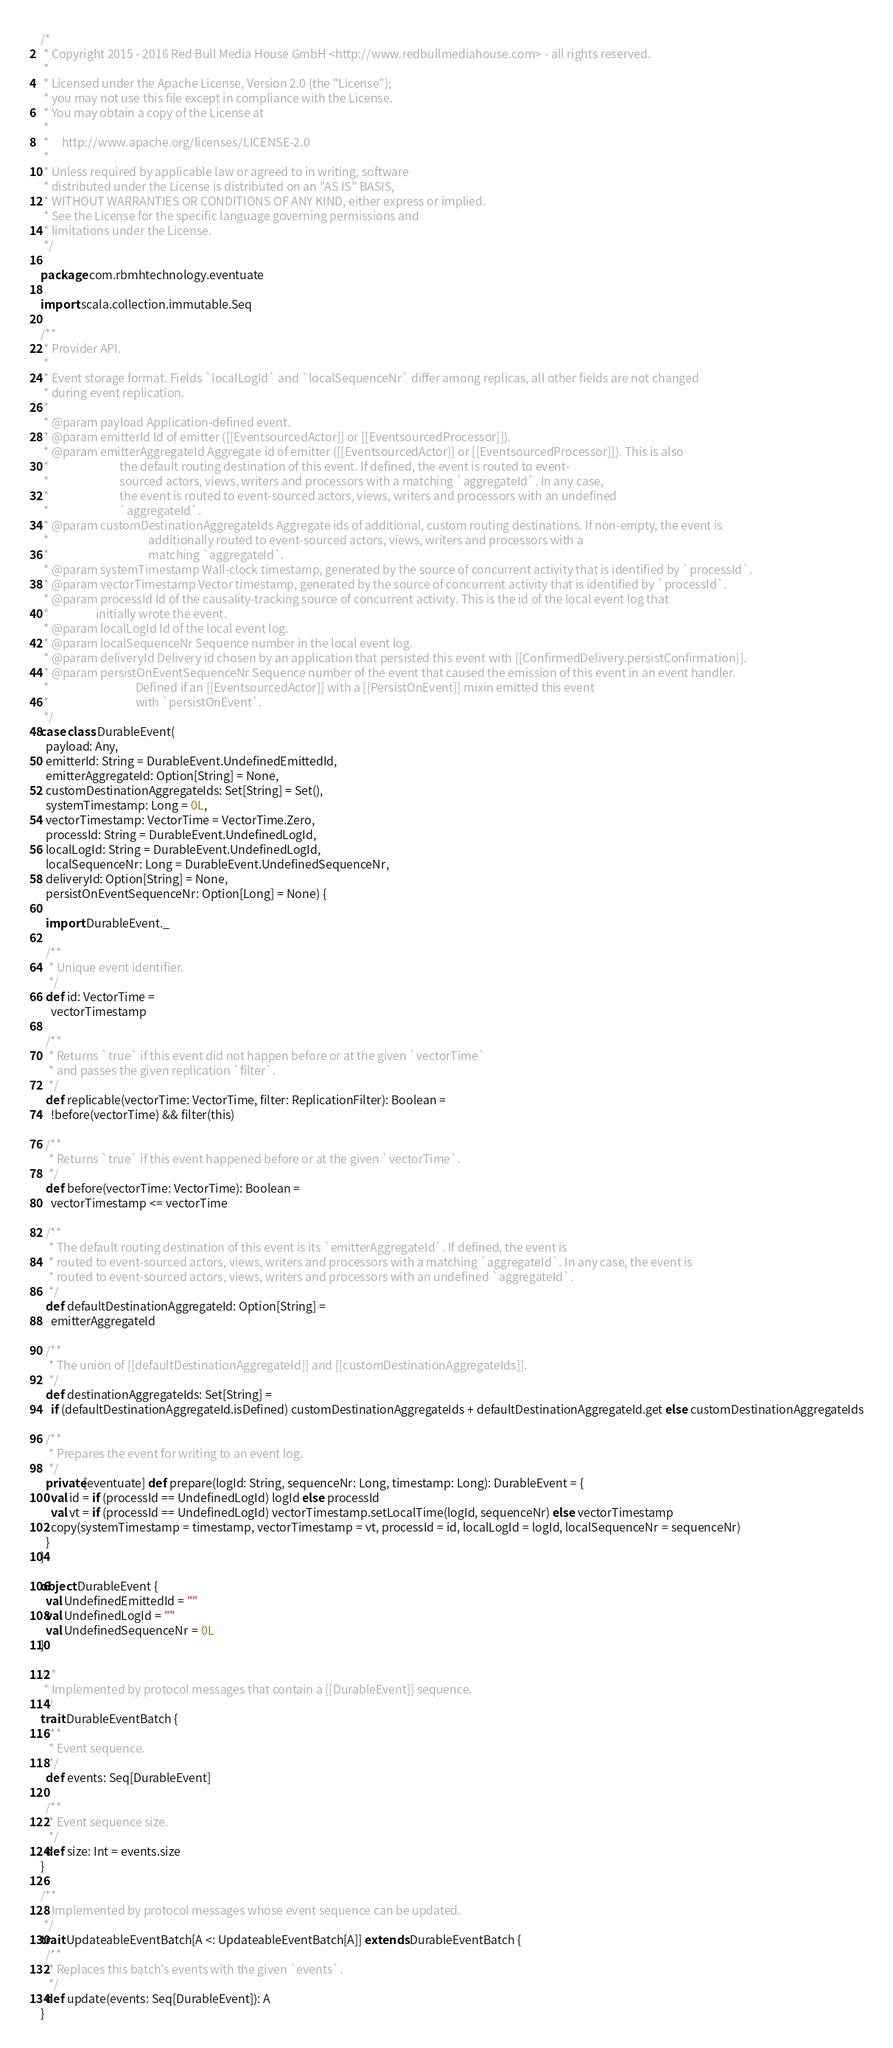Convert code to text. <code><loc_0><loc_0><loc_500><loc_500><_Scala_>/*
 * Copyright 2015 - 2016 Red Bull Media House GmbH <http://www.redbullmediahouse.com> - all rights reserved.
 *
 * Licensed under the Apache License, Version 2.0 (the "License");
 * you may not use this file except in compliance with the License.
 * You may obtain a copy of the License at
 *
 *     http://www.apache.org/licenses/LICENSE-2.0
 *
 * Unless required by applicable law or agreed to in writing, software
 * distributed under the License is distributed on an "AS IS" BASIS,
 * WITHOUT WARRANTIES OR CONDITIONS OF ANY KIND, either express or implied.
 * See the License for the specific language governing permissions and
 * limitations under the License.
 */

package com.rbmhtechnology.eventuate

import scala.collection.immutable.Seq

/**
 * Provider API.
 *
 * Event storage format. Fields `localLogId` and `localSequenceNr` differ among replicas, all other fields are not changed
 * during event replication.
 *
 * @param payload Application-defined event.
 * @param emitterId Id of emitter ([[EventsourcedActor]] or [[EventsourcedProcessor]]).
 * @param emitterAggregateId Aggregate id of emitter ([[EventsourcedActor]] or [[EventsourcedProcessor]]). This is also
 *                           the default routing destination of this event. If defined, the event is routed to event-
 *                           sourced actors, views, writers and processors with a matching `aggregateId`. In any case,
 *                           the event is routed to event-sourced actors, views, writers and processors with an undefined
 *                           `aggregateId`.
 * @param customDestinationAggregateIds Aggregate ids of additional, custom routing destinations. If non-empty, the event is
 *                                      additionally routed to event-sourced actors, views, writers and processors with a
 *                                      matching `aggregateId`.
 * @param systemTimestamp Wall-clock timestamp, generated by the source of concurrent activity that is identified by `processId`.
 * @param vectorTimestamp Vector timestamp, generated by the source of concurrent activity that is identified by `processId`.
 * @param processId Id of the causality-tracking source of concurrent activity. This is the id of the local event log that
 *                  initially wrote the event.
 * @param localLogId Id of the local event log.
 * @param localSequenceNr Sequence number in the local event log.
 * @param deliveryId Delivery id chosen by an application that persisted this event with [[ConfirmedDelivery.persistConfirmation]].
 * @param persistOnEventSequenceNr Sequence number of the event that caused the emission of this event in an event handler.
 *                                 Defined if an [[EventsourcedActor]] with a [[PersistOnEvent]] mixin emitted this event
 *                                 with `persistOnEvent`.
 */
case class DurableEvent(
  payload: Any,
  emitterId: String = DurableEvent.UndefinedEmittedId,
  emitterAggregateId: Option[String] = None,
  customDestinationAggregateIds: Set[String] = Set(),
  systemTimestamp: Long = 0L,
  vectorTimestamp: VectorTime = VectorTime.Zero,
  processId: String = DurableEvent.UndefinedLogId,
  localLogId: String = DurableEvent.UndefinedLogId,
  localSequenceNr: Long = DurableEvent.UndefinedSequenceNr,
  deliveryId: Option[String] = None,
  persistOnEventSequenceNr: Option[Long] = None) {

  import DurableEvent._

  /**
   * Unique event identifier.
   */
  def id: VectorTime =
    vectorTimestamp

  /**
   * Returns `true` if this event did not happen before or at the given `vectorTime`
   * and passes the given replication `filter`.
   */
  def replicable(vectorTime: VectorTime, filter: ReplicationFilter): Boolean =
    !before(vectorTime) && filter(this)

  /**
   * Returns `true` if this event happened before or at the given `vectorTime`.
   */
  def before(vectorTime: VectorTime): Boolean =
    vectorTimestamp <= vectorTime

  /**
   * The default routing destination of this event is its `emitterAggregateId`. If defined, the event is
   * routed to event-sourced actors, views, writers and processors with a matching `aggregateId`. In any case, the event is
   * routed to event-sourced actors, views, writers and processors with an undefined `aggregateId`.
   */
  def defaultDestinationAggregateId: Option[String] =
    emitterAggregateId

  /**
   * The union of [[defaultDestinationAggregateId]] and [[customDestinationAggregateIds]].
   */
  def destinationAggregateIds: Set[String] =
    if (defaultDestinationAggregateId.isDefined) customDestinationAggregateIds + defaultDestinationAggregateId.get else customDestinationAggregateIds

  /**
   * Prepares the event for writing to an event log.
   */
  private[eventuate] def prepare(logId: String, sequenceNr: Long, timestamp: Long): DurableEvent = {
    val id = if (processId == UndefinedLogId) logId else processId
    val vt = if (processId == UndefinedLogId) vectorTimestamp.setLocalTime(logId, sequenceNr) else vectorTimestamp
    copy(systemTimestamp = timestamp, vectorTimestamp = vt, processId = id, localLogId = logId, localSequenceNr = sequenceNr)
  }
}

object DurableEvent {
  val UndefinedEmittedId = ""
  val UndefinedLogId = ""
  val UndefinedSequenceNr = 0L
}

/**
 * Implemented by protocol messages that contain a [[DurableEvent]] sequence.
 */
trait DurableEventBatch {
  /**
   * Event sequence.
   */
  def events: Seq[DurableEvent]

  /**
   * Event sequence size.
   */
  def size: Int = events.size
}

/**
 * Implemented by protocol messages whose event sequence can be updated.
 */
trait UpdateableEventBatch[A <: UpdateableEventBatch[A]] extends DurableEventBatch {
  /**
   * Replaces this batch's events with the given `events`.
   */
  def update(events: Seq[DurableEvent]): A
}
</code> 